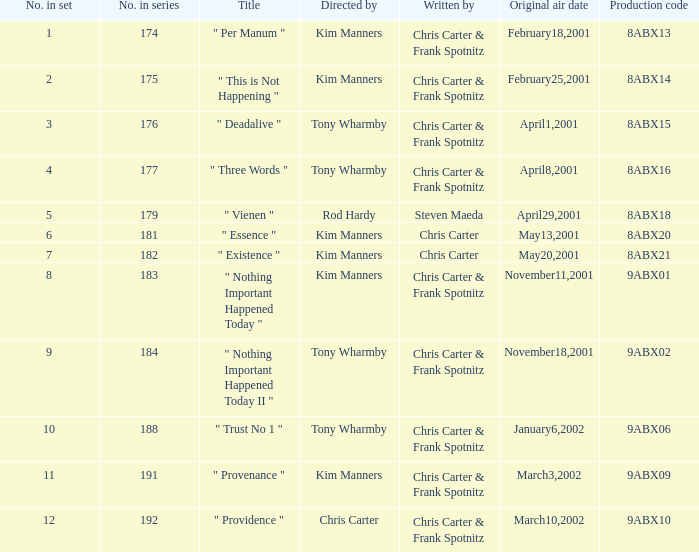Would you be able to parse every entry in this table? {'header': ['No. in set', 'No. in series', 'Title', 'Directed by', 'Written by', 'Original air date', 'Production code'], 'rows': [['1', '174', '" Per Manum "', 'Kim Manners', 'Chris Carter & Frank Spotnitz', 'February18,2001', '8ABX13'], ['2', '175', '" This is Not Happening "', 'Kim Manners', 'Chris Carter & Frank Spotnitz', 'February25,2001', '8ABX14'], ['3', '176', '" Deadalive "', 'Tony Wharmby', 'Chris Carter & Frank Spotnitz', 'April1,2001', '8ABX15'], ['4', '177', '" Three Words "', 'Tony Wharmby', 'Chris Carter & Frank Spotnitz', 'April8,2001', '8ABX16'], ['5', '179', '" Vienen "', 'Rod Hardy', 'Steven Maeda', 'April29,2001', '8ABX18'], ['6', '181', '" Essence "', 'Kim Manners', 'Chris Carter', 'May13,2001', '8ABX20'], ['7', '182', '" Existence "', 'Kim Manners', 'Chris Carter', 'May20,2001', '8ABX21'], ['8', '183', '" Nothing Important Happened Today "', 'Kim Manners', 'Chris Carter & Frank Spotnitz', 'November11,2001', '9ABX01'], ['9', '184', '" Nothing Important Happened Today II "', 'Tony Wharmby', 'Chris Carter & Frank Spotnitz', 'November18,2001', '9ABX02'], ['10', '188', '" Trust No 1 "', 'Tony Wharmby', 'Chris Carter & Frank Spotnitz', 'January6,2002', '9ABX06'], ['11', '191', '" Provenance "', 'Kim Manners', 'Chris Carter & Frank Spotnitz', 'March3,2002', '9ABX09'], ['12', '192', '" Providence "', 'Chris Carter', 'Chris Carter & Frank Spotnitz', 'March10,2002', '9ABX10']]} What is the number of the episode with the production code 8abx15? 176.0. 